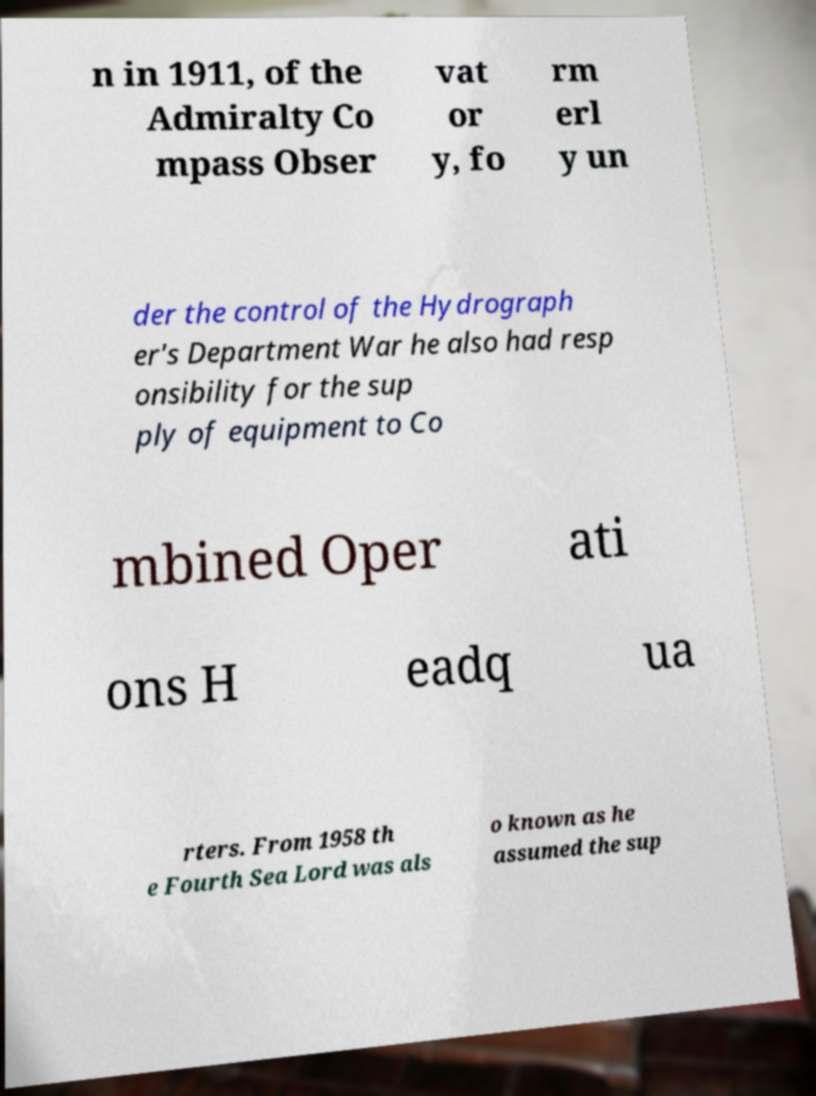Please read and relay the text visible in this image. What does it say? n in 1911, of the Admiralty Co mpass Obser vat or y, fo rm erl y un der the control of the Hydrograph er's Department War he also had resp onsibility for the sup ply of equipment to Co mbined Oper ati ons H eadq ua rters. From 1958 th e Fourth Sea Lord was als o known as he assumed the sup 